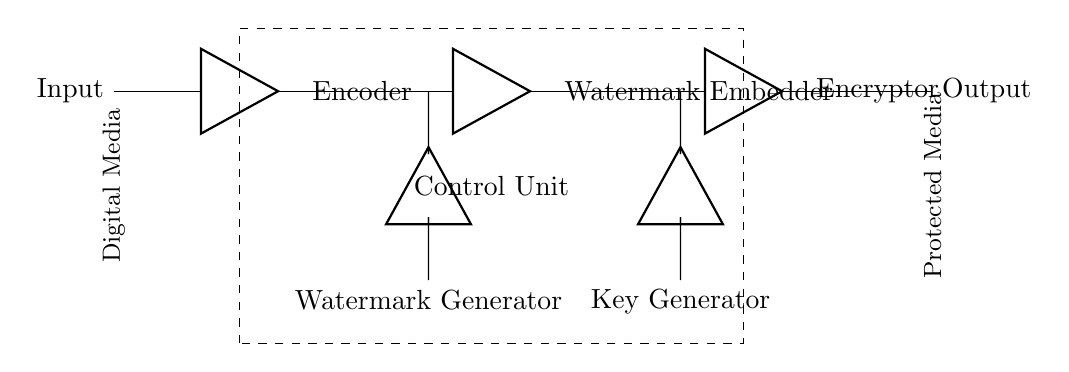What is the main input to the circuit? The main input to the circuit is labeled as "Input" on the left side of the diagram, indicating where the digital media signal enters the system.
Answer: Input What is the function of the "Watermark Embedder"? The "Watermark Embedder" is the component responsible for embedding the watermark into the digital media signal, which is essential for protection against unauthorized use.
Answer: Embed watermark What is the purpose of the "Control Unit"? The "Control Unit" orchestrates the operations of the various components in the circuit, ensuring that the watermark generation, embedding, and encryption processes are synchronized.
Answer: Orchestrates components How many components are directly connected in series after the input? There are three components connected in series after the input: the "Encoder," "Watermark Embedder," and "Encryptor."
Answer: Three What does the "Key Generator" produce? The "Key Generator" produces cryptographic keys necessary for the encryption process, which is essential for securing the embedded watermark.
Answer: Cryptographic keys What task does the "Watermark Generator" perform? The "Watermark Generator" creates the actual watermark data that will be embedded into the digital media, making it a crucial part of the watermarking function.
Answer: Creates watermark data What is the final output of the circuit? The final output of the circuit is labeled as "Output," representing the protected media after watermarking and encryption.
Answer: Protected media 